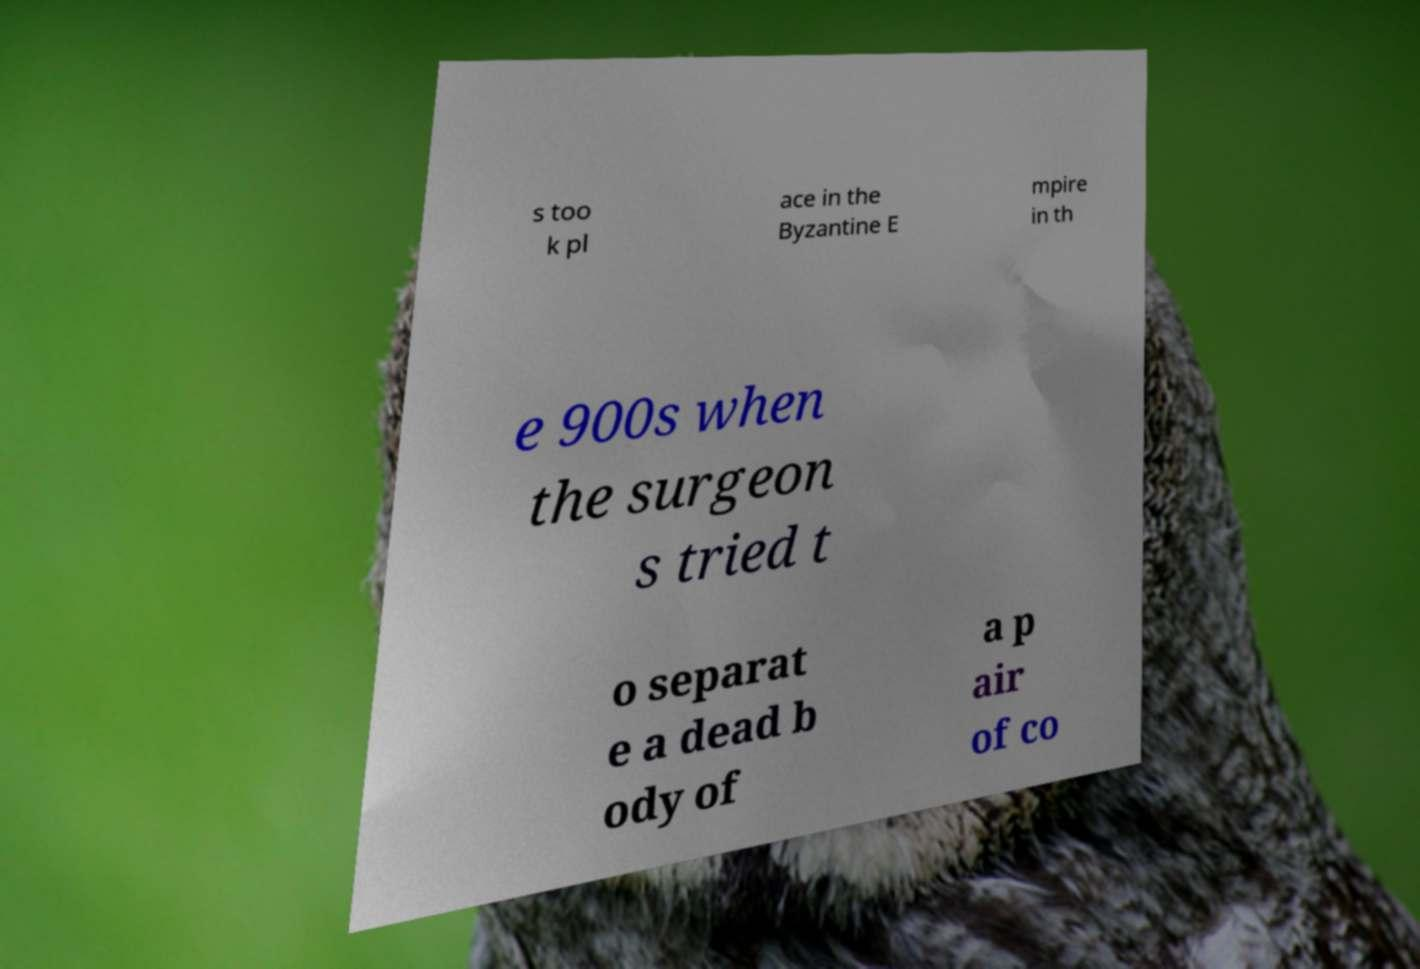What messages or text are displayed in this image? I need them in a readable, typed format. s too k pl ace in the Byzantine E mpire in th e 900s when the surgeon s tried t o separat e a dead b ody of a p air of co 